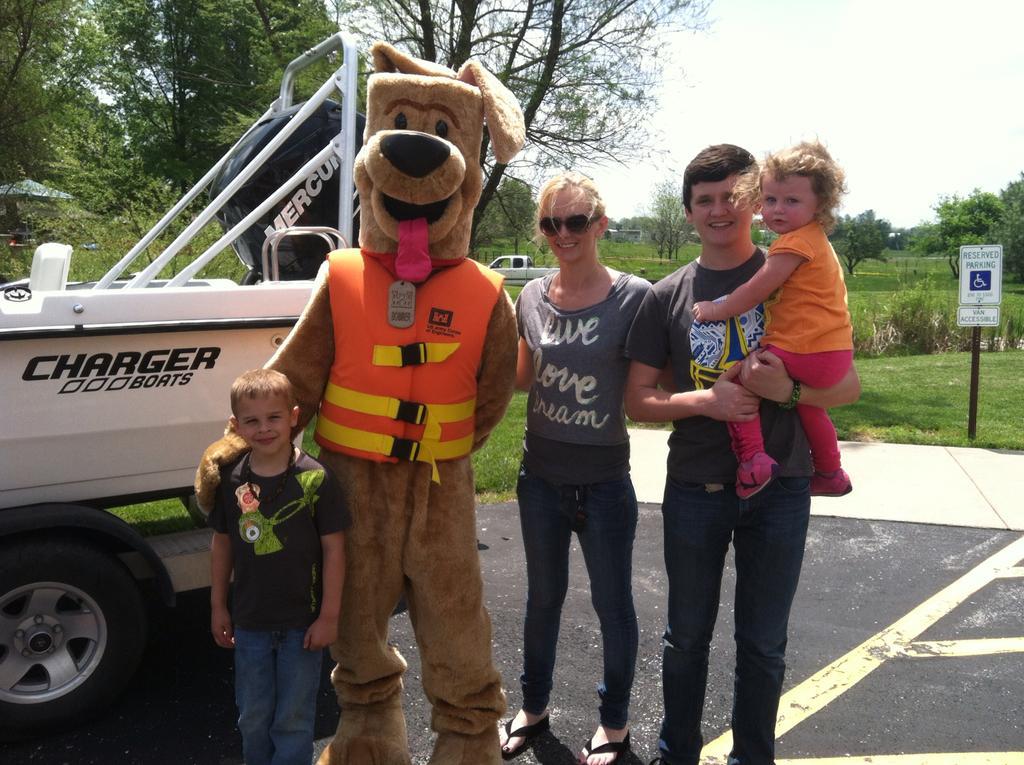In one or two sentences, can you explain what this image depicts? In this picture we can see some people standing on the road and smiling, vehicles, trees, signboard, grass and in the background we can see the sky. 